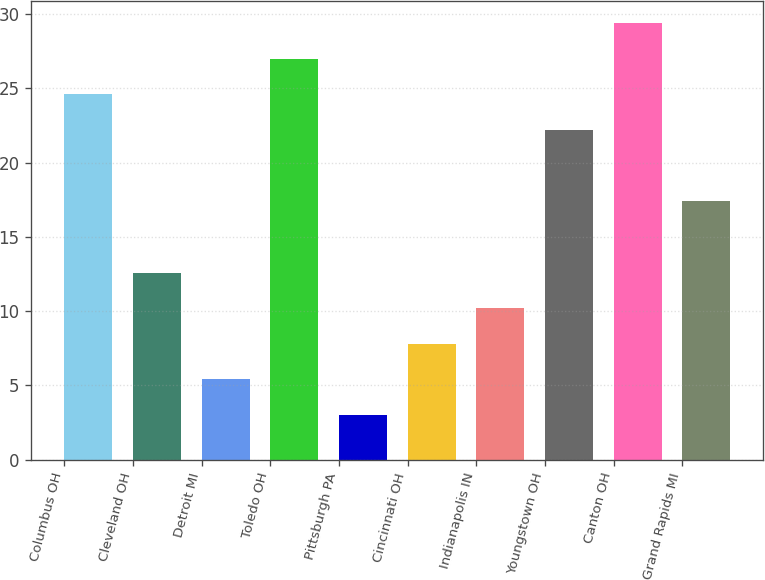Convert chart to OTSL. <chart><loc_0><loc_0><loc_500><loc_500><bar_chart><fcel>Columbus OH<fcel>Cleveland OH<fcel>Detroit MI<fcel>Toledo OH<fcel>Pittsburgh PA<fcel>Cincinnati OH<fcel>Indianapolis IN<fcel>Youngstown OH<fcel>Canton OH<fcel>Grand Rapids MI<nl><fcel>24.6<fcel>12.6<fcel>5.4<fcel>27<fcel>3<fcel>7.8<fcel>10.2<fcel>22.2<fcel>29.4<fcel>17.4<nl></chart> 